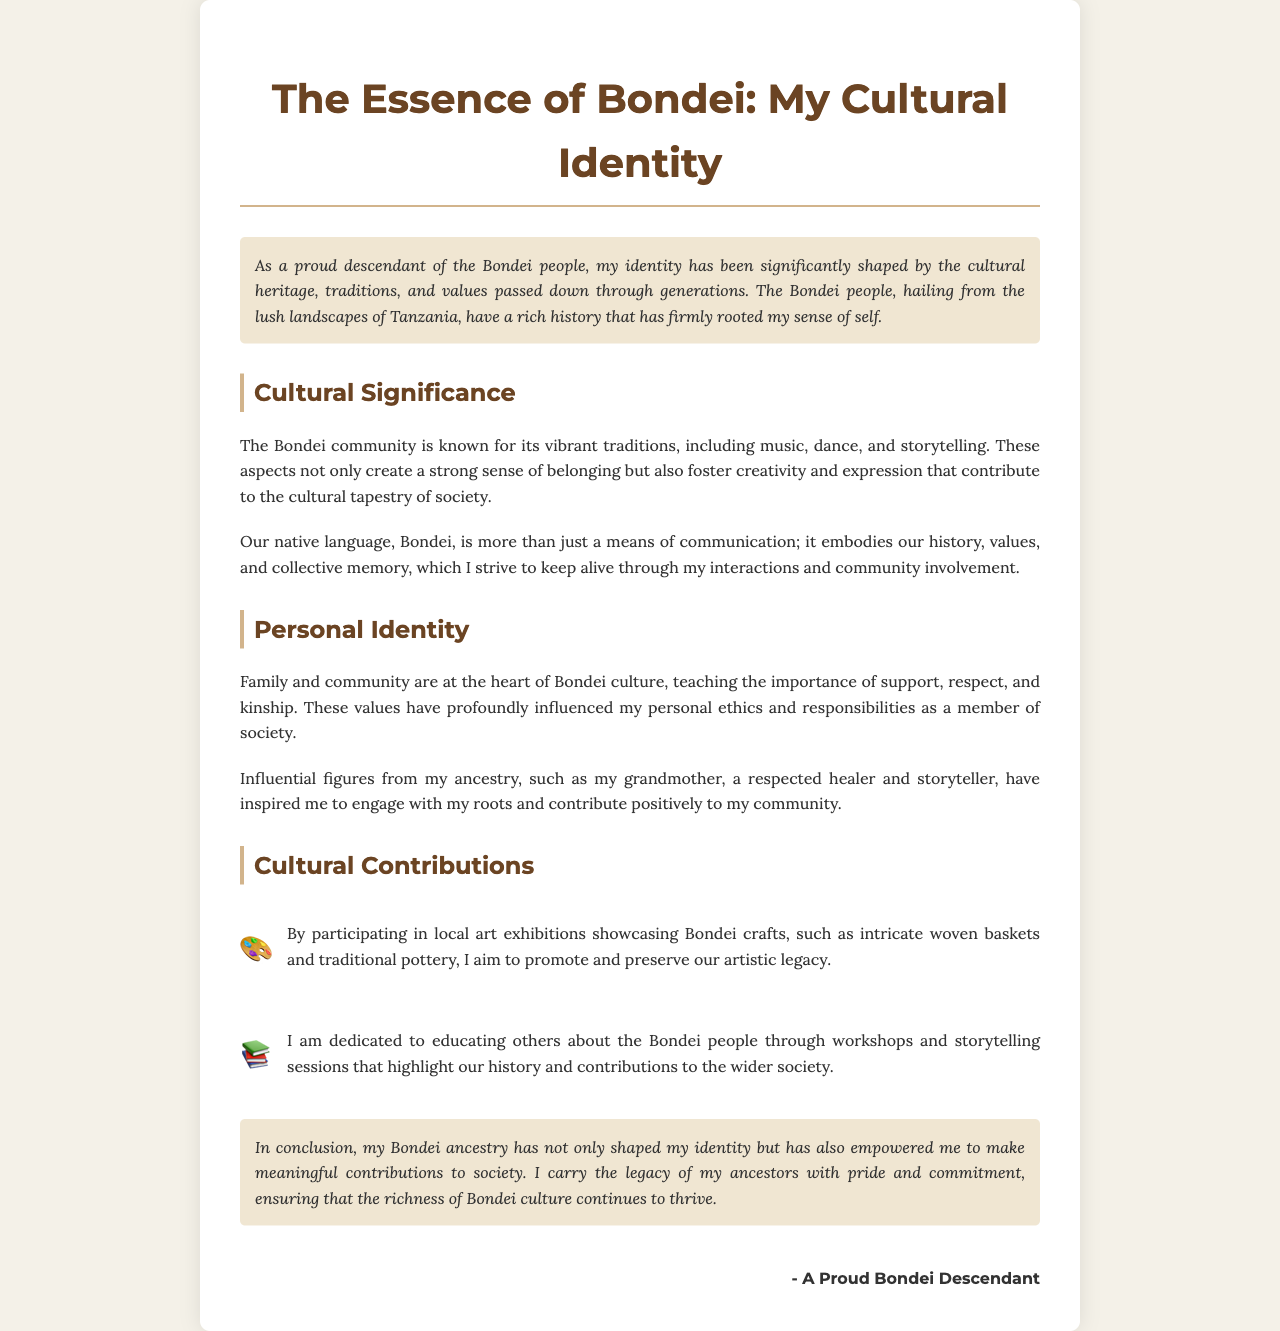What is the title of the document? The title of the document is found at the top of the letter, presenting the main subject.
Answer: The Essence of Bondei: My Cultural Identity What community is the document centered on? The document discusses the identity, culture, and contributions of a specific ethnic group.
Answer: Bondei What two aspects of Bondei culture are mentioned in the document? The document lists cultural elements that are significant to the Bondei community.
Answer: Music, dance Who inspired the author to engage with their roots? An influential figure from the author's ancestry is mentioned as a source of inspiration.
Answer: Grandmother What type of crafts does the author promote through local art exhibitions? The author highlights specific artistic heritage that they aim to preserve through their efforts.
Answer: Woven baskets What does the author do to educate others about the Bondei people? The author describes specific activities aimed at raising awareness and understanding of their culture.
Answer: Workshops How is the Bondei language described in the document? The document outlines the significance of the Bondei language to the community and author.
Answer: Embodies our history What is emphasized as central to Bondei culture? The document highlights key values that are integral to Bondei social life and relationships.
Answer: Family and community 